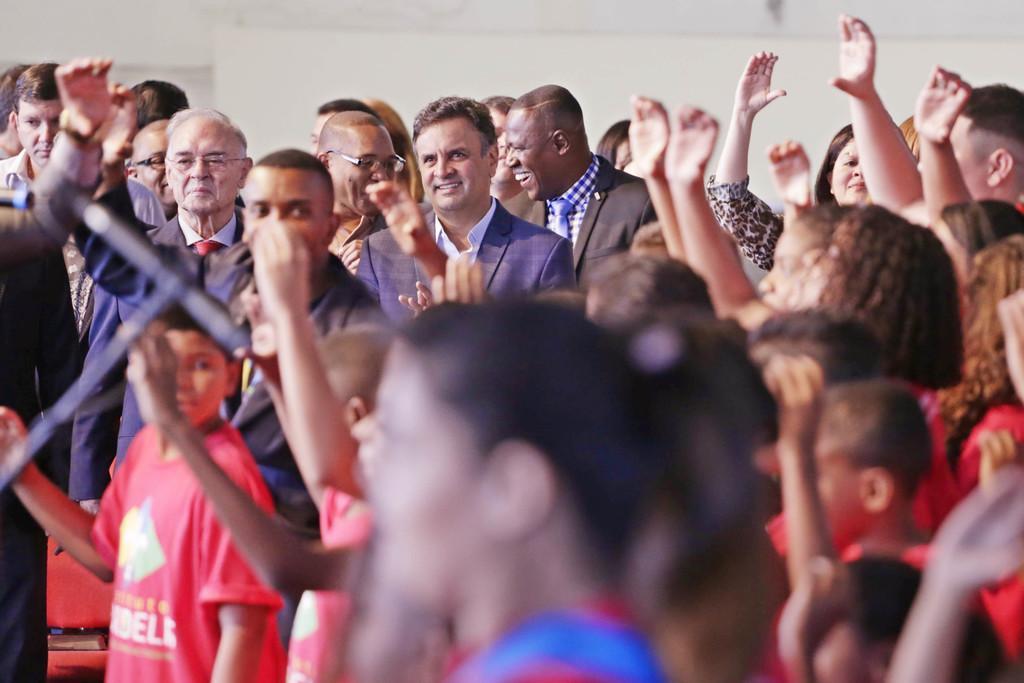Can you describe this image briefly? In this picture we can see a group of people are standing and some of them are raising the hands. On the left side of the image we can see a mic with stand and chair. At the top of the image we can see the wall and roof. 